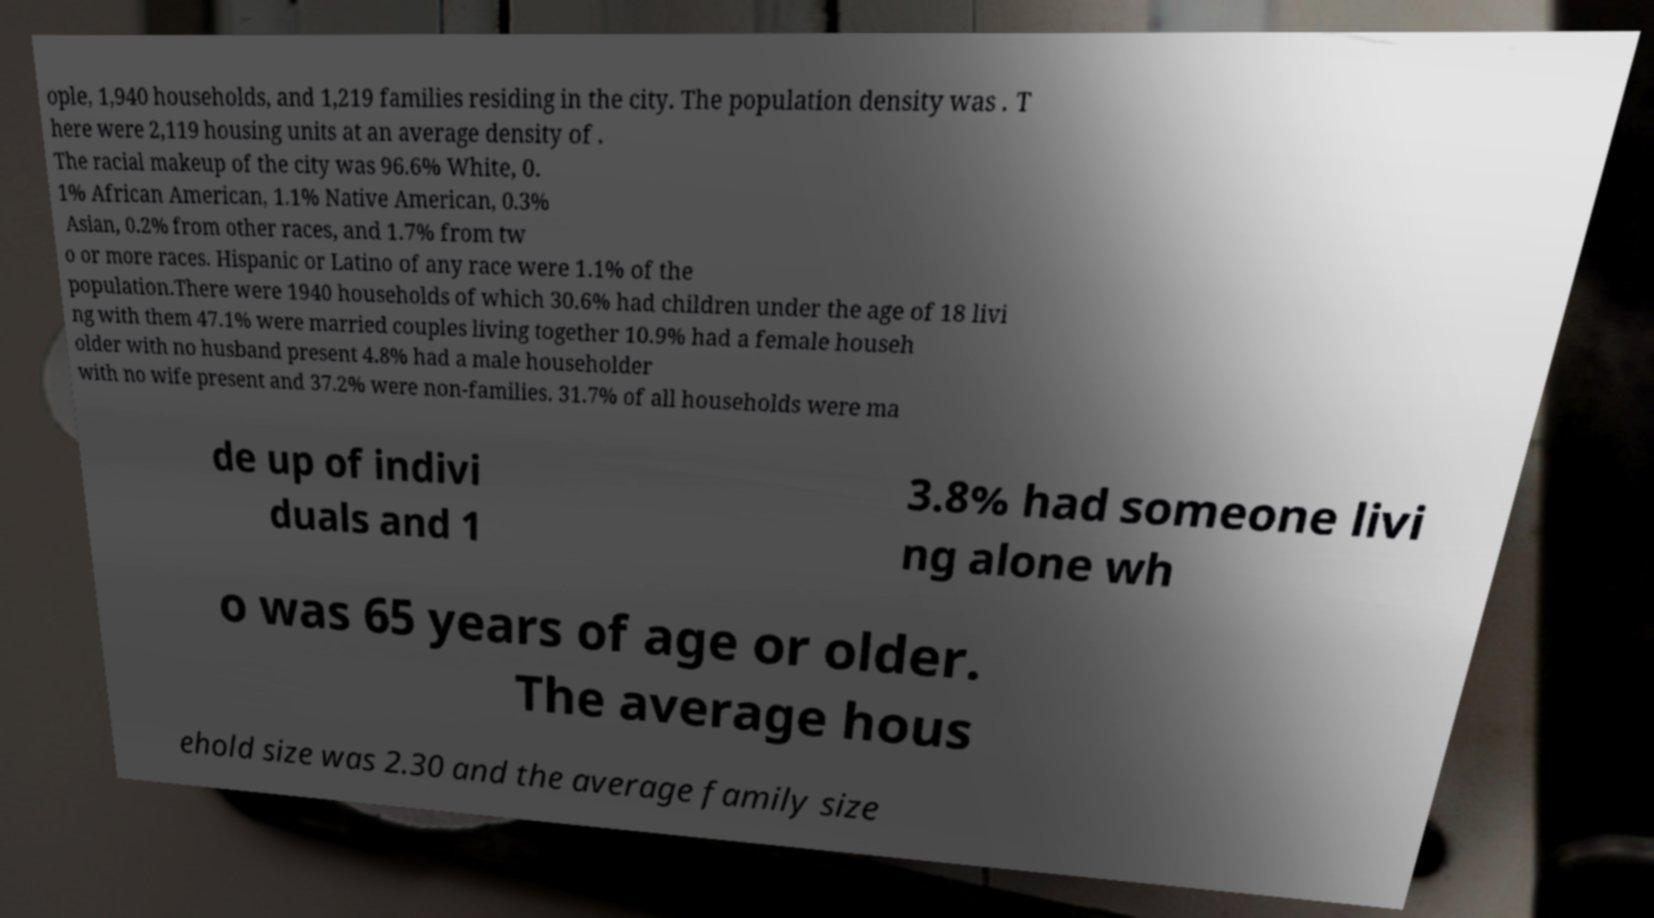Can you read and provide the text displayed in the image?This photo seems to have some interesting text. Can you extract and type it out for me? ople, 1,940 households, and 1,219 families residing in the city. The population density was . T here were 2,119 housing units at an average density of . The racial makeup of the city was 96.6% White, 0. 1% African American, 1.1% Native American, 0.3% Asian, 0.2% from other races, and 1.7% from tw o or more races. Hispanic or Latino of any race were 1.1% of the population.There were 1940 households of which 30.6% had children under the age of 18 livi ng with them 47.1% were married couples living together 10.9% had a female househ older with no husband present 4.8% had a male householder with no wife present and 37.2% were non-families. 31.7% of all households were ma de up of indivi duals and 1 3.8% had someone livi ng alone wh o was 65 years of age or older. The average hous ehold size was 2.30 and the average family size 